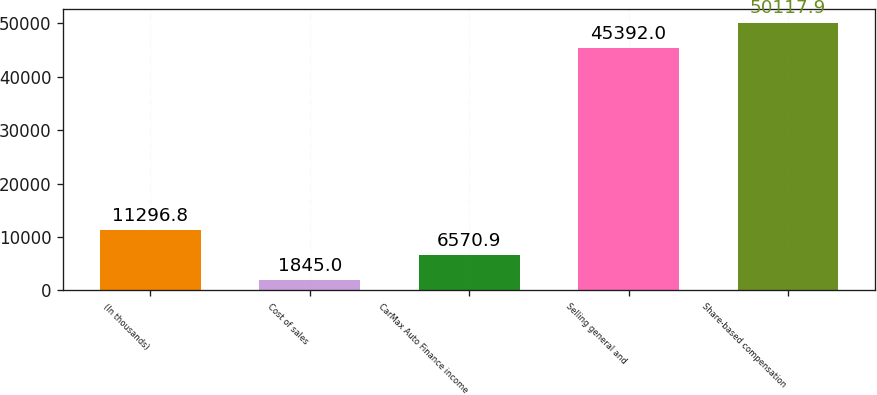Convert chart to OTSL. <chart><loc_0><loc_0><loc_500><loc_500><bar_chart><fcel>(In thousands)<fcel>Cost of sales<fcel>CarMax Auto Finance income<fcel>Selling general and<fcel>Share-based compensation<nl><fcel>11296.8<fcel>1845<fcel>6570.9<fcel>45392<fcel>50117.9<nl></chart> 